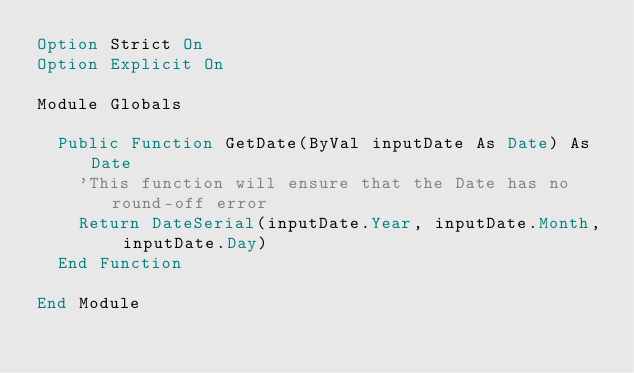Convert code to text. <code><loc_0><loc_0><loc_500><loc_500><_VisualBasic_>Option Strict On
Option Explicit On 

Module Globals

  Public Function GetDate(ByVal inputDate As Date) As Date
    'This function will ensure that the Date has no round-off error
    Return DateSerial(inputDate.Year, inputDate.Month, inputDate.Day)
  End Function

End Module
</code> 